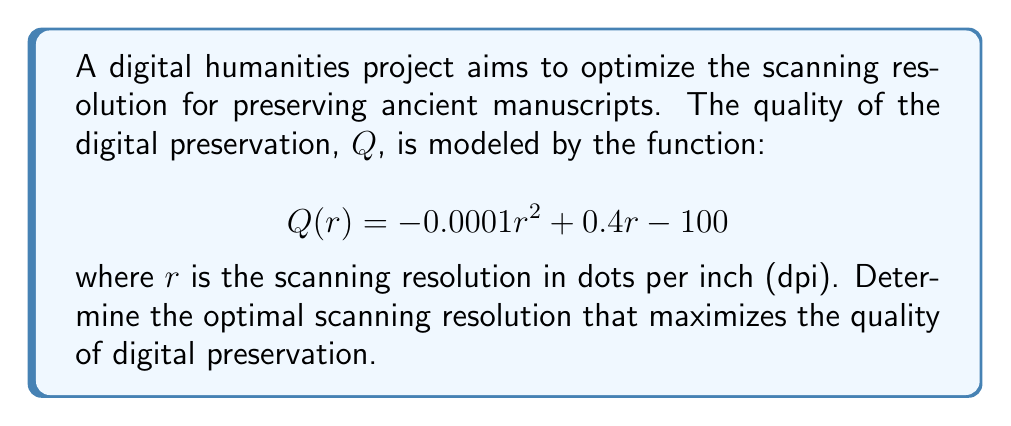Can you answer this question? To find the optimal scanning resolution, we need to determine the maximum value of the quality function $Q(r)$. This can be done using differential calculus:

1) First, find the derivative of $Q(r)$ with respect to $r$:
   $$Q'(r) = -0.0002r + 0.4$$

2) To find the critical point, set $Q'(r) = 0$ and solve for $r$:
   $$-0.0002r + 0.4 = 0$$
   $$-0.0002r = -0.4$$
   $$r = 2000$$

3) To confirm this is a maximum, check the second derivative:
   $$Q''(r) = -0.0002$$

   Since $Q''(r)$ is negative, the critical point is a maximum.

4) Therefore, the optimal scanning resolution is 2000 dpi.

5) We can verify this by evaluating $Q(r)$ at this point:
   $$Q(2000) = -0.0001(2000)^2 + 0.4(2000) - 100 = 300$$

This is indeed the maximum value of $Q(r)$.
Answer: 2000 dpi 